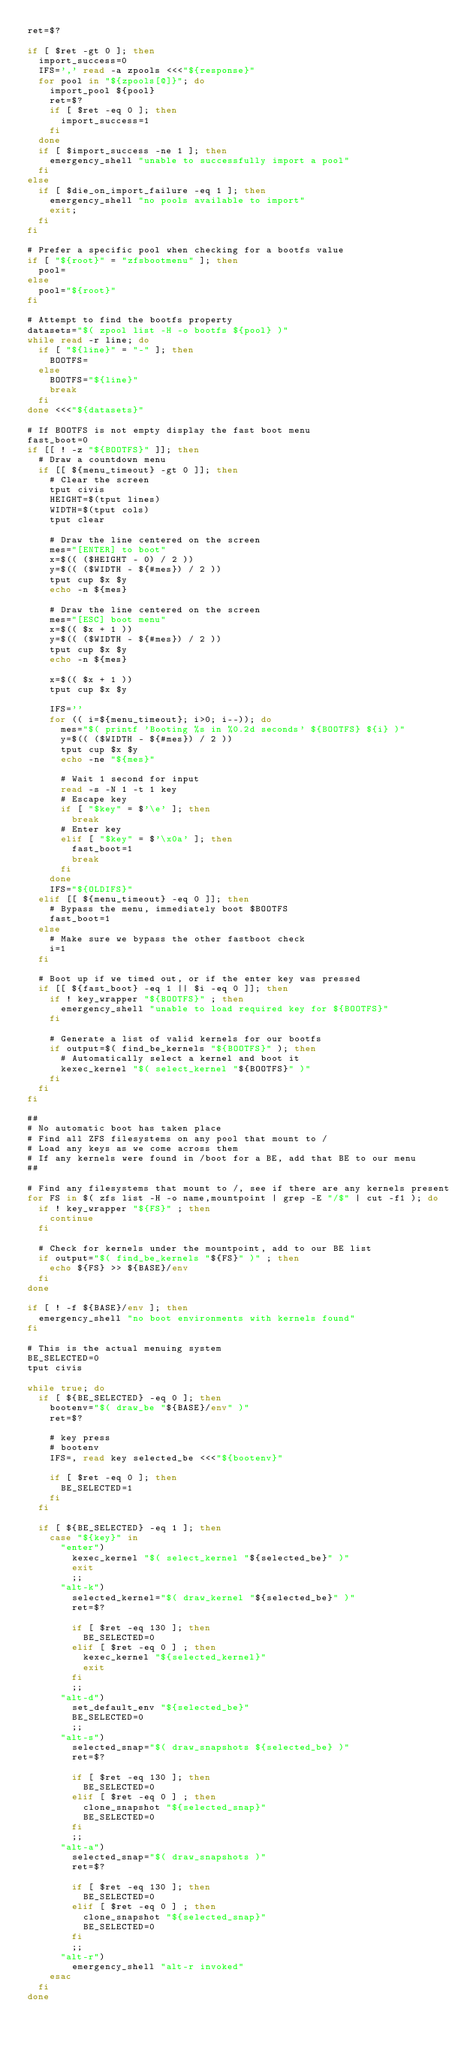Convert code to text. <code><loc_0><loc_0><loc_500><loc_500><_Bash_>ret=$?

if [ $ret -gt 0 ]; then
  import_success=0
  IFS=',' read -a zpools <<<"${response}"
  for pool in "${zpools[@]}"; do
    import_pool ${pool}
    ret=$?
    if [ $ret -eq 0 ]; then
      import_success=1
    fi
  done
  if [ $import_success -ne 1 ]; then
    emergency_shell "unable to successfully import a pool"
  fi
else
  if [ $die_on_import_failure -eq 1 ]; then
    emergency_shell "no pools available to import"
    exit;
  fi
fi

# Prefer a specific pool when checking for a bootfs value
if [ "${root}" = "zfsbootmenu" ]; then
  pool=
else
  pool="${root}"
fi

# Attempt to find the bootfs property 
datasets="$( zpool list -H -o bootfs ${pool} )"
while read -r line; do
  if [ "${line}" = "-" ]; then
    BOOTFS=
  else
    BOOTFS="${line}"
    break
  fi
done <<<"${datasets}"

# If BOOTFS is not empty display the fast boot menu
fast_boot=0
if [[ ! -z "${BOOTFS}" ]]; then
  # Draw a countdown menu
  if [[ ${menu_timeout} -gt 0 ]]; then
    # Clear the screen
    tput civis
    HEIGHT=$(tput lines)
    WIDTH=$(tput cols)
    tput clear

    # Draw the line centered on the screen
    mes="[ENTER] to boot"
    x=$(( ($HEIGHT - 0) / 2 ))
    y=$(( ($WIDTH - ${#mes}) / 2 ))
    tput cup $x $y
    echo -n ${mes}

    # Draw the line centered on the screen
    mes="[ESC] boot menu"
    x=$(( $x + 1 ))
    y=$(( ($WIDTH - ${#mes}) / 2 ))
    tput cup $x $y
    echo -n ${mes}

    x=$(( $x + 1 ))
    tput cup $x $y

    IFS=''
    for (( i=${menu_timeout}; i>0; i--)); do
      mes="$( printf 'Booting %s in %0.2d seconds' ${BOOTFS} ${i} )"
      y=$(( ($WIDTH - ${#mes}) / 2 ))
      tput cup $x $y
      echo -ne "${mes}"

      # Wait 1 second for input
      read -s -N 1 -t 1 key
      # Escape key
      if [ "$key" = $'\e' ]; then
        break
      # Enter key
      elif [ "$key" = $'\x0a' ]; then
        fast_boot=1
        break
      fi
    done
    IFS="${OLDIFS}"
  elif [[ ${menu_timeout} -eq 0 ]]; then
    # Bypass the menu, immediately boot $BOOTFS
    fast_boot=1
  else
    # Make sure we bypass the other fastboot check
    i=1
  fi
  
  # Boot up if we timed out, or if the enter key was pressed
  if [[ ${fast_boot} -eq 1 || $i -eq 0 ]]; then
    if ! key_wrapper "${BOOTFS}" ; then
      emergency_shell "unable to load required key for ${BOOTFS}"
    fi

    # Generate a list of valid kernels for our bootfs
    if output=$( find_be_kernels "${BOOTFS}" ); then
      # Automatically select a kernel and boot it
      kexec_kernel "$( select_kernel "${BOOTFS}" )"
    fi
  fi
fi

##
# No automatic boot has taken place
# Find all ZFS filesystems on any pool that mount to /
# Load any keys as we come across them
# If any kernels were found in /boot for a BE, add that BE to our menu
##

# Find any filesystems that mount to /, see if there are any kernels present
for FS in $( zfs list -H -o name,mountpoint | grep -E "/$" | cut -f1 ); do
  if ! key_wrapper "${FS}" ; then
    continue
  fi

  # Check for kernels under the mountpoint, add to our BE list
  if output="$( find_be_kernels "${FS}" )" ; then
    echo ${FS} >> ${BASE}/env
  fi
done

if [ ! -f ${BASE}/env ]; then
  emergency_shell "no boot environments with kernels found"
fi

# This is the actual menuing system
BE_SELECTED=0
tput civis

while true; do
  if [ ${BE_SELECTED} -eq 0 ]; then
    bootenv="$( draw_be "${BASE}/env" )"
    ret=$?
    
    # key press
    # bootenv
    IFS=, read key selected_be <<<"${bootenv}"

    if [ $ret -eq 0 ]; then
      BE_SELECTED=1
    fi
  fi

  if [ ${BE_SELECTED} -eq 1 ]; then
    case "${key}" in
      "enter")
        kexec_kernel "$( select_kernel "${selected_be}" )"
        exit
        ;;
      "alt-k")
        selected_kernel="$( draw_kernel "${selected_be}" )"
        ret=$?

        if [ $ret -eq 130 ]; then
          BE_SELECTED=0 
        elif [ $ret -eq 0 ] ; then
          kexec_kernel "${selected_kernel}"
          exit
        fi
        ;;
      "alt-d")
        set_default_env "${selected_be}"
        BE_SELECTED=0
        ;;
      "alt-s")
        selected_snap="$( draw_snapshots ${selected_be} )"
        ret=$?

        if [ $ret -eq 130 ]; then
          BE_SELECTED=0 
        elif [ $ret -eq 0 ] ; then
          clone_snapshot "${selected_snap}"
          BE_SELECTED=0 
        fi
        ;;
      "alt-a")
        selected_snap="$( draw_snapshots )"
        ret=$?

        if [ $ret -eq 130 ]; then
          BE_SELECTED=0 
        elif [ $ret -eq 0 ] ; then
          clone_snapshot "${selected_snap}"
          BE_SELECTED=0 
        fi
        ;;
      "alt-r")
        emergency_shell "alt-r invoked"
    esac
  fi
done
</code> 